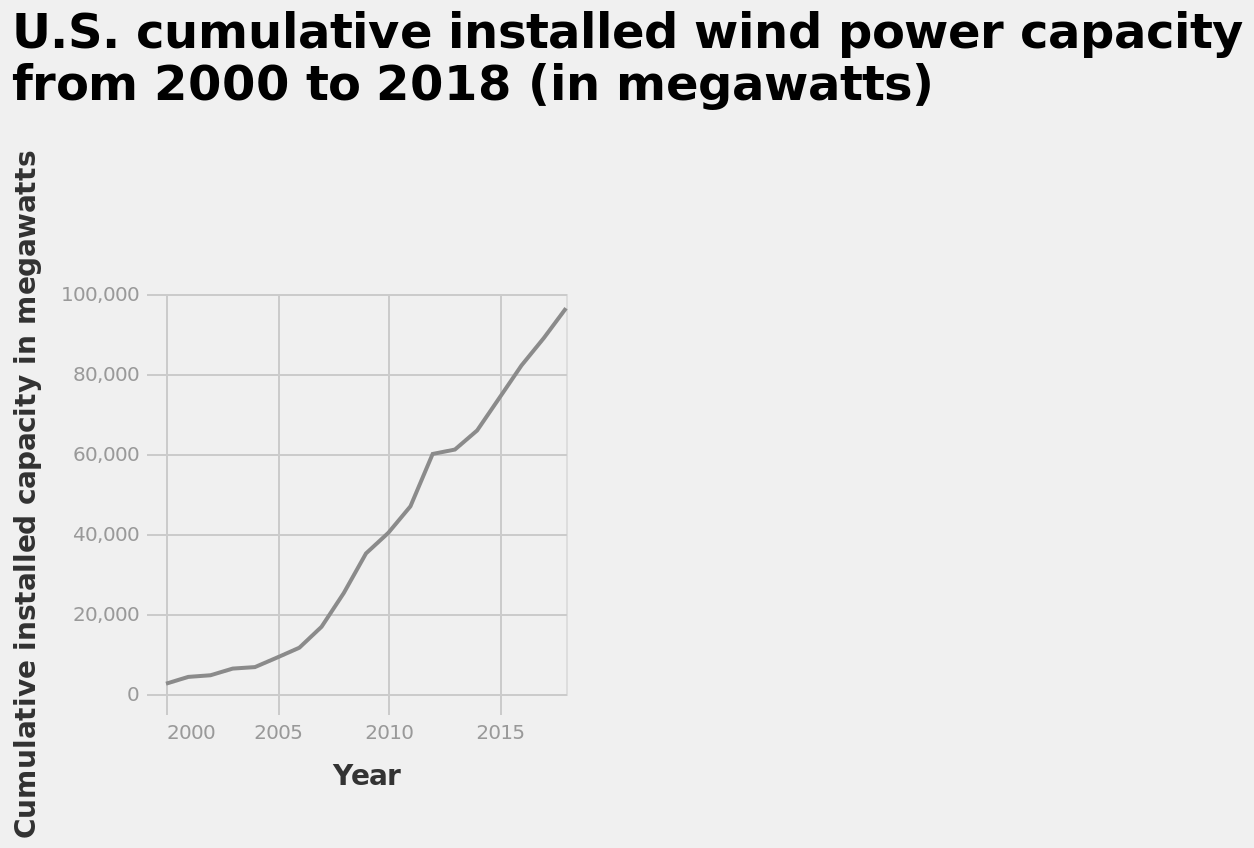<image>
What is the range of the y-axis in the line graph?  The y-axis range in the line graph is from 0 to 100,000 megawatts. During which years was the cumulative installed capacity of wind power measured? The cumulative installed capacity of wind power was measured between 2000 and 2018. How many years of data are included in the graph? The graph includes data from 2000 to 2018, so there are 19 years of data. 